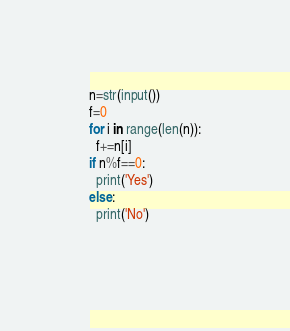<code> <loc_0><loc_0><loc_500><loc_500><_Python_>n=str(input())
f=0
for i in range(len(n)):
  f+=n[i]
if n%f==0:
  print('Yes')
else:
  print('No')
  </code> 